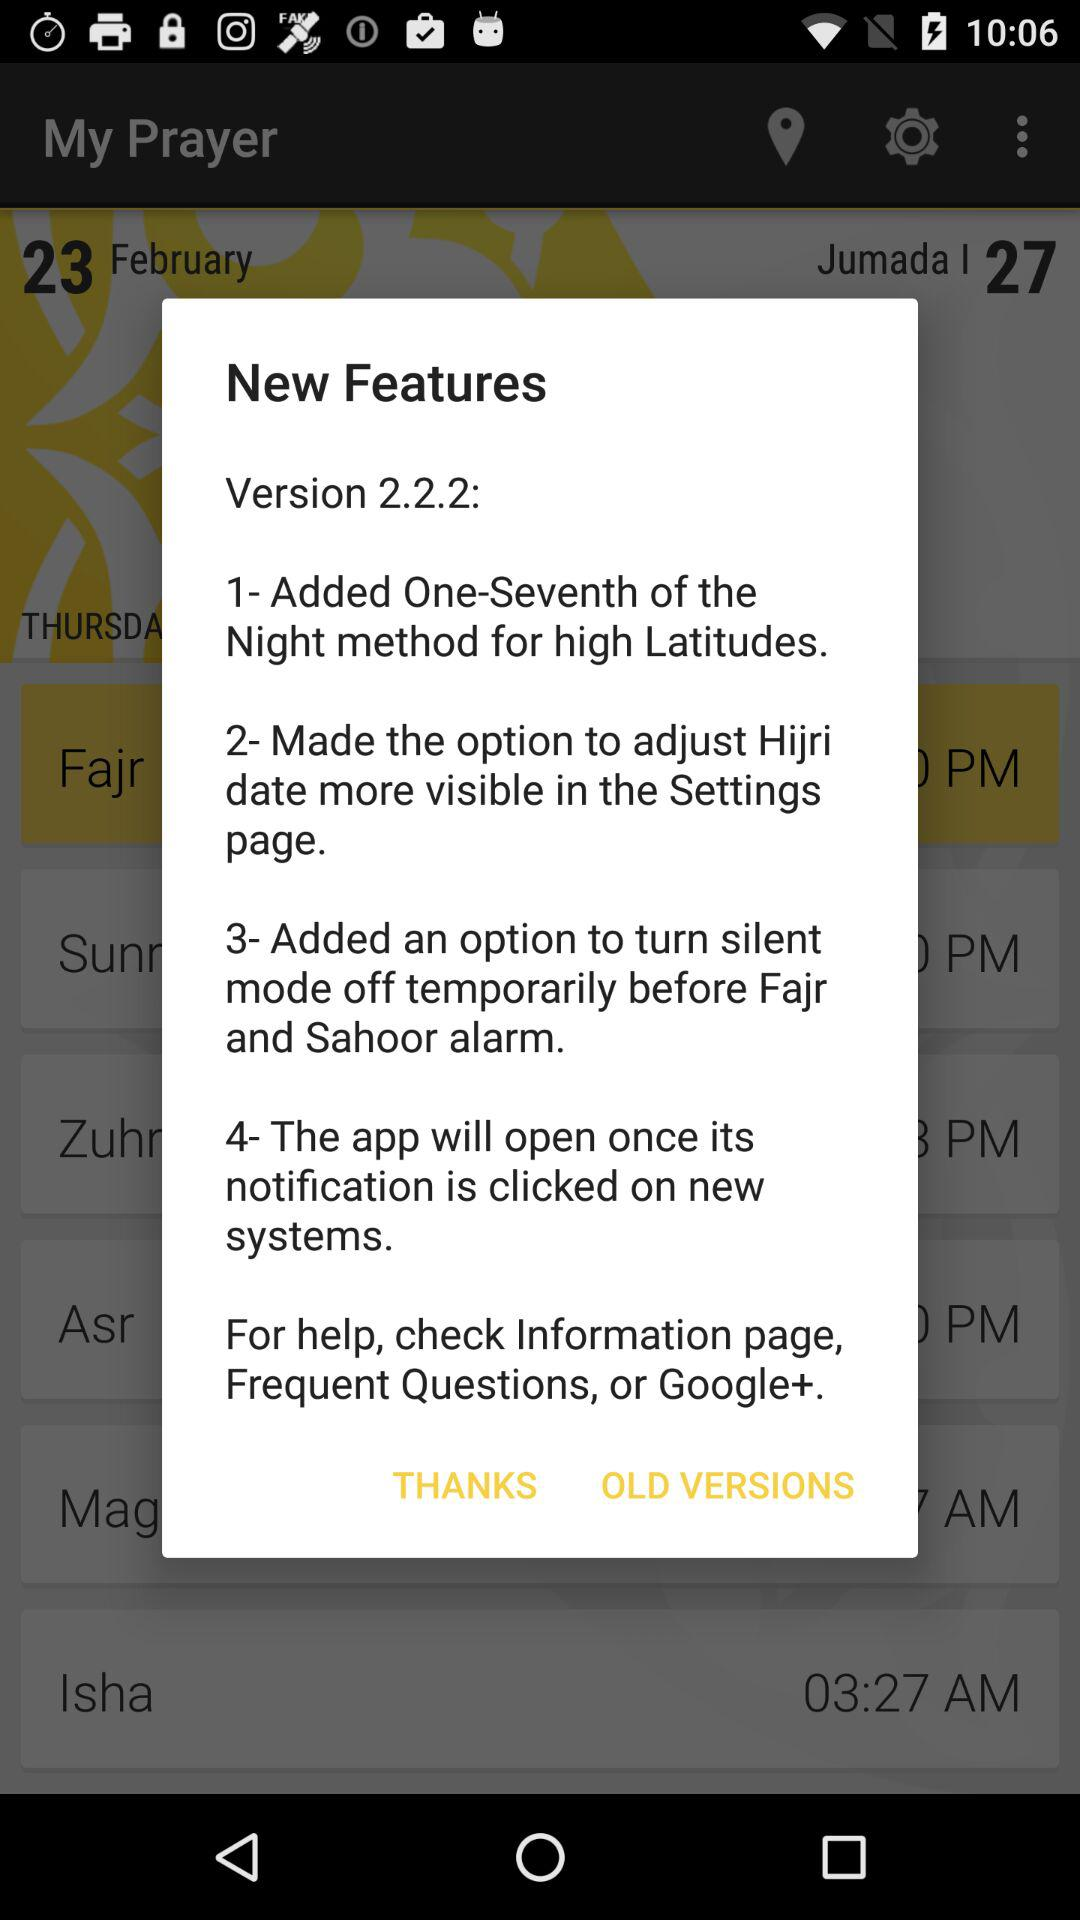How many features have been added?
Answer the question using a single word or phrase. 4 